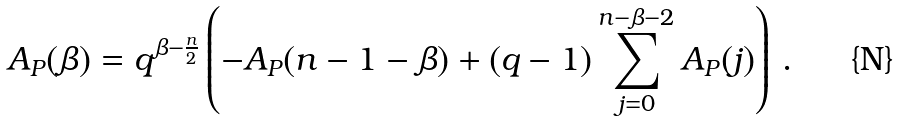<formula> <loc_0><loc_0><loc_500><loc_500>A _ { P } ( \beta ) = q ^ { \beta - \frac { n } { 2 } } \left ( - A _ { P } ( n - 1 - \beta ) + ( q - 1 ) \sum _ { j = 0 } ^ { n - \beta - 2 } A _ { P } ( j ) \right ) \, .</formula> 